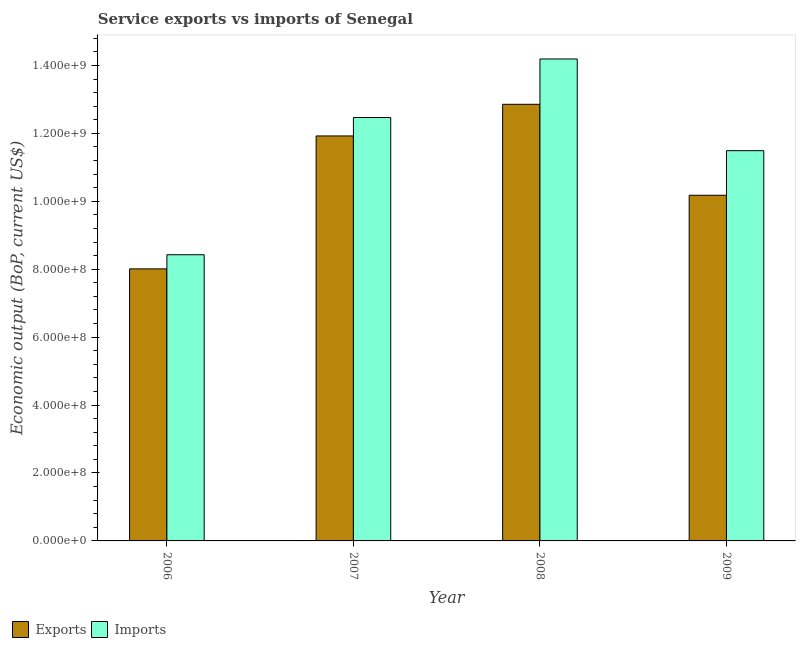How many different coloured bars are there?
Your answer should be compact. 2. How many groups of bars are there?
Provide a short and direct response. 4. How many bars are there on the 4th tick from the right?
Make the answer very short. 2. In how many cases, is the number of bars for a given year not equal to the number of legend labels?
Your answer should be compact. 0. What is the amount of service imports in 2008?
Offer a very short reply. 1.42e+09. Across all years, what is the maximum amount of service imports?
Your response must be concise. 1.42e+09. Across all years, what is the minimum amount of service exports?
Provide a short and direct response. 8.01e+08. What is the total amount of service imports in the graph?
Your answer should be very brief. 4.66e+09. What is the difference between the amount of service exports in 2008 and that in 2009?
Make the answer very short. 2.68e+08. What is the difference between the amount of service imports in 2008 and the amount of service exports in 2009?
Your answer should be very brief. 2.70e+08. What is the average amount of service exports per year?
Provide a short and direct response. 1.07e+09. In how many years, is the amount of service imports greater than 1280000000 US$?
Your answer should be compact. 1. What is the ratio of the amount of service imports in 2007 to that in 2009?
Give a very brief answer. 1.08. Is the difference between the amount of service exports in 2007 and 2009 greater than the difference between the amount of service imports in 2007 and 2009?
Give a very brief answer. No. What is the difference between the highest and the second highest amount of service imports?
Provide a short and direct response. 1.72e+08. What is the difference between the highest and the lowest amount of service imports?
Give a very brief answer. 5.76e+08. In how many years, is the amount of service imports greater than the average amount of service imports taken over all years?
Provide a short and direct response. 2. What does the 1st bar from the left in 2009 represents?
Provide a succinct answer. Exports. What does the 1st bar from the right in 2007 represents?
Your response must be concise. Imports. How many bars are there?
Ensure brevity in your answer.  8. Are all the bars in the graph horizontal?
Give a very brief answer. No. Are the values on the major ticks of Y-axis written in scientific E-notation?
Make the answer very short. Yes. Does the graph contain grids?
Ensure brevity in your answer.  No. Where does the legend appear in the graph?
Your response must be concise. Bottom left. What is the title of the graph?
Offer a terse response. Service exports vs imports of Senegal. Does "Age 15+" appear as one of the legend labels in the graph?
Your response must be concise. No. What is the label or title of the X-axis?
Provide a succinct answer. Year. What is the label or title of the Y-axis?
Your answer should be very brief. Economic output (BoP, current US$). What is the Economic output (BoP, current US$) of Exports in 2006?
Give a very brief answer. 8.01e+08. What is the Economic output (BoP, current US$) of Imports in 2006?
Provide a short and direct response. 8.43e+08. What is the Economic output (BoP, current US$) of Exports in 2007?
Your answer should be compact. 1.19e+09. What is the Economic output (BoP, current US$) in Imports in 2007?
Ensure brevity in your answer.  1.25e+09. What is the Economic output (BoP, current US$) in Exports in 2008?
Your response must be concise. 1.29e+09. What is the Economic output (BoP, current US$) of Imports in 2008?
Make the answer very short. 1.42e+09. What is the Economic output (BoP, current US$) of Exports in 2009?
Your response must be concise. 1.02e+09. What is the Economic output (BoP, current US$) in Imports in 2009?
Keep it short and to the point. 1.15e+09. Across all years, what is the maximum Economic output (BoP, current US$) of Exports?
Provide a short and direct response. 1.29e+09. Across all years, what is the maximum Economic output (BoP, current US$) of Imports?
Make the answer very short. 1.42e+09. Across all years, what is the minimum Economic output (BoP, current US$) of Exports?
Give a very brief answer. 8.01e+08. Across all years, what is the minimum Economic output (BoP, current US$) in Imports?
Your response must be concise. 8.43e+08. What is the total Economic output (BoP, current US$) of Exports in the graph?
Make the answer very short. 4.30e+09. What is the total Economic output (BoP, current US$) in Imports in the graph?
Ensure brevity in your answer.  4.66e+09. What is the difference between the Economic output (BoP, current US$) of Exports in 2006 and that in 2007?
Provide a succinct answer. -3.91e+08. What is the difference between the Economic output (BoP, current US$) of Imports in 2006 and that in 2007?
Your answer should be very brief. -4.04e+08. What is the difference between the Economic output (BoP, current US$) in Exports in 2006 and that in 2008?
Offer a very short reply. -4.85e+08. What is the difference between the Economic output (BoP, current US$) of Imports in 2006 and that in 2008?
Offer a terse response. -5.76e+08. What is the difference between the Economic output (BoP, current US$) in Exports in 2006 and that in 2009?
Make the answer very short. -2.17e+08. What is the difference between the Economic output (BoP, current US$) of Imports in 2006 and that in 2009?
Ensure brevity in your answer.  -3.06e+08. What is the difference between the Economic output (BoP, current US$) in Exports in 2007 and that in 2008?
Provide a succinct answer. -9.32e+07. What is the difference between the Economic output (BoP, current US$) of Imports in 2007 and that in 2008?
Offer a very short reply. -1.72e+08. What is the difference between the Economic output (BoP, current US$) of Exports in 2007 and that in 2009?
Offer a terse response. 1.75e+08. What is the difference between the Economic output (BoP, current US$) of Imports in 2007 and that in 2009?
Your response must be concise. 9.76e+07. What is the difference between the Economic output (BoP, current US$) of Exports in 2008 and that in 2009?
Give a very brief answer. 2.68e+08. What is the difference between the Economic output (BoP, current US$) of Imports in 2008 and that in 2009?
Ensure brevity in your answer.  2.70e+08. What is the difference between the Economic output (BoP, current US$) of Exports in 2006 and the Economic output (BoP, current US$) of Imports in 2007?
Your answer should be very brief. -4.46e+08. What is the difference between the Economic output (BoP, current US$) of Exports in 2006 and the Economic output (BoP, current US$) of Imports in 2008?
Keep it short and to the point. -6.18e+08. What is the difference between the Economic output (BoP, current US$) in Exports in 2006 and the Economic output (BoP, current US$) in Imports in 2009?
Your answer should be very brief. -3.48e+08. What is the difference between the Economic output (BoP, current US$) in Exports in 2007 and the Economic output (BoP, current US$) in Imports in 2008?
Give a very brief answer. -2.27e+08. What is the difference between the Economic output (BoP, current US$) in Exports in 2007 and the Economic output (BoP, current US$) in Imports in 2009?
Offer a terse response. 4.34e+07. What is the difference between the Economic output (BoP, current US$) of Exports in 2008 and the Economic output (BoP, current US$) of Imports in 2009?
Offer a very short reply. 1.37e+08. What is the average Economic output (BoP, current US$) of Exports per year?
Provide a short and direct response. 1.07e+09. What is the average Economic output (BoP, current US$) in Imports per year?
Ensure brevity in your answer.  1.16e+09. In the year 2006, what is the difference between the Economic output (BoP, current US$) in Exports and Economic output (BoP, current US$) in Imports?
Your answer should be very brief. -4.16e+07. In the year 2007, what is the difference between the Economic output (BoP, current US$) in Exports and Economic output (BoP, current US$) in Imports?
Give a very brief answer. -5.42e+07. In the year 2008, what is the difference between the Economic output (BoP, current US$) in Exports and Economic output (BoP, current US$) in Imports?
Keep it short and to the point. -1.33e+08. In the year 2009, what is the difference between the Economic output (BoP, current US$) of Exports and Economic output (BoP, current US$) of Imports?
Give a very brief answer. -1.31e+08. What is the ratio of the Economic output (BoP, current US$) of Exports in 2006 to that in 2007?
Ensure brevity in your answer.  0.67. What is the ratio of the Economic output (BoP, current US$) in Imports in 2006 to that in 2007?
Offer a very short reply. 0.68. What is the ratio of the Economic output (BoP, current US$) of Exports in 2006 to that in 2008?
Your response must be concise. 0.62. What is the ratio of the Economic output (BoP, current US$) in Imports in 2006 to that in 2008?
Offer a very short reply. 0.59. What is the ratio of the Economic output (BoP, current US$) in Exports in 2006 to that in 2009?
Offer a very short reply. 0.79. What is the ratio of the Economic output (BoP, current US$) in Imports in 2006 to that in 2009?
Make the answer very short. 0.73. What is the ratio of the Economic output (BoP, current US$) of Exports in 2007 to that in 2008?
Offer a terse response. 0.93. What is the ratio of the Economic output (BoP, current US$) in Imports in 2007 to that in 2008?
Keep it short and to the point. 0.88. What is the ratio of the Economic output (BoP, current US$) in Exports in 2007 to that in 2009?
Offer a very short reply. 1.17. What is the ratio of the Economic output (BoP, current US$) of Imports in 2007 to that in 2009?
Provide a short and direct response. 1.08. What is the ratio of the Economic output (BoP, current US$) of Exports in 2008 to that in 2009?
Provide a short and direct response. 1.26. What is the ratio of the Economic output (BoP, current US$) in Imports in 2008 to that in 2009?
Give a very brief answer. 1.24. What is the difference between the highest and the second highest Economic output (BoP, current US$) in Exports?
Provide a short and direct response. 9.32e+07. What is the difference between the highest and the second highest Economic output (BoP, current US$) in Imports?
Offer a very short reply. 1.72e+08. What is the difference between the highest and the lowest Economic output (BoP, current US$) of Exports?
Make the answer very short. 4.85e+08. What is the difference between the highest and the lowest Economic output (BoP, current US$) of Imports?
Ensure brevity in your answer.  5.76e+08. 